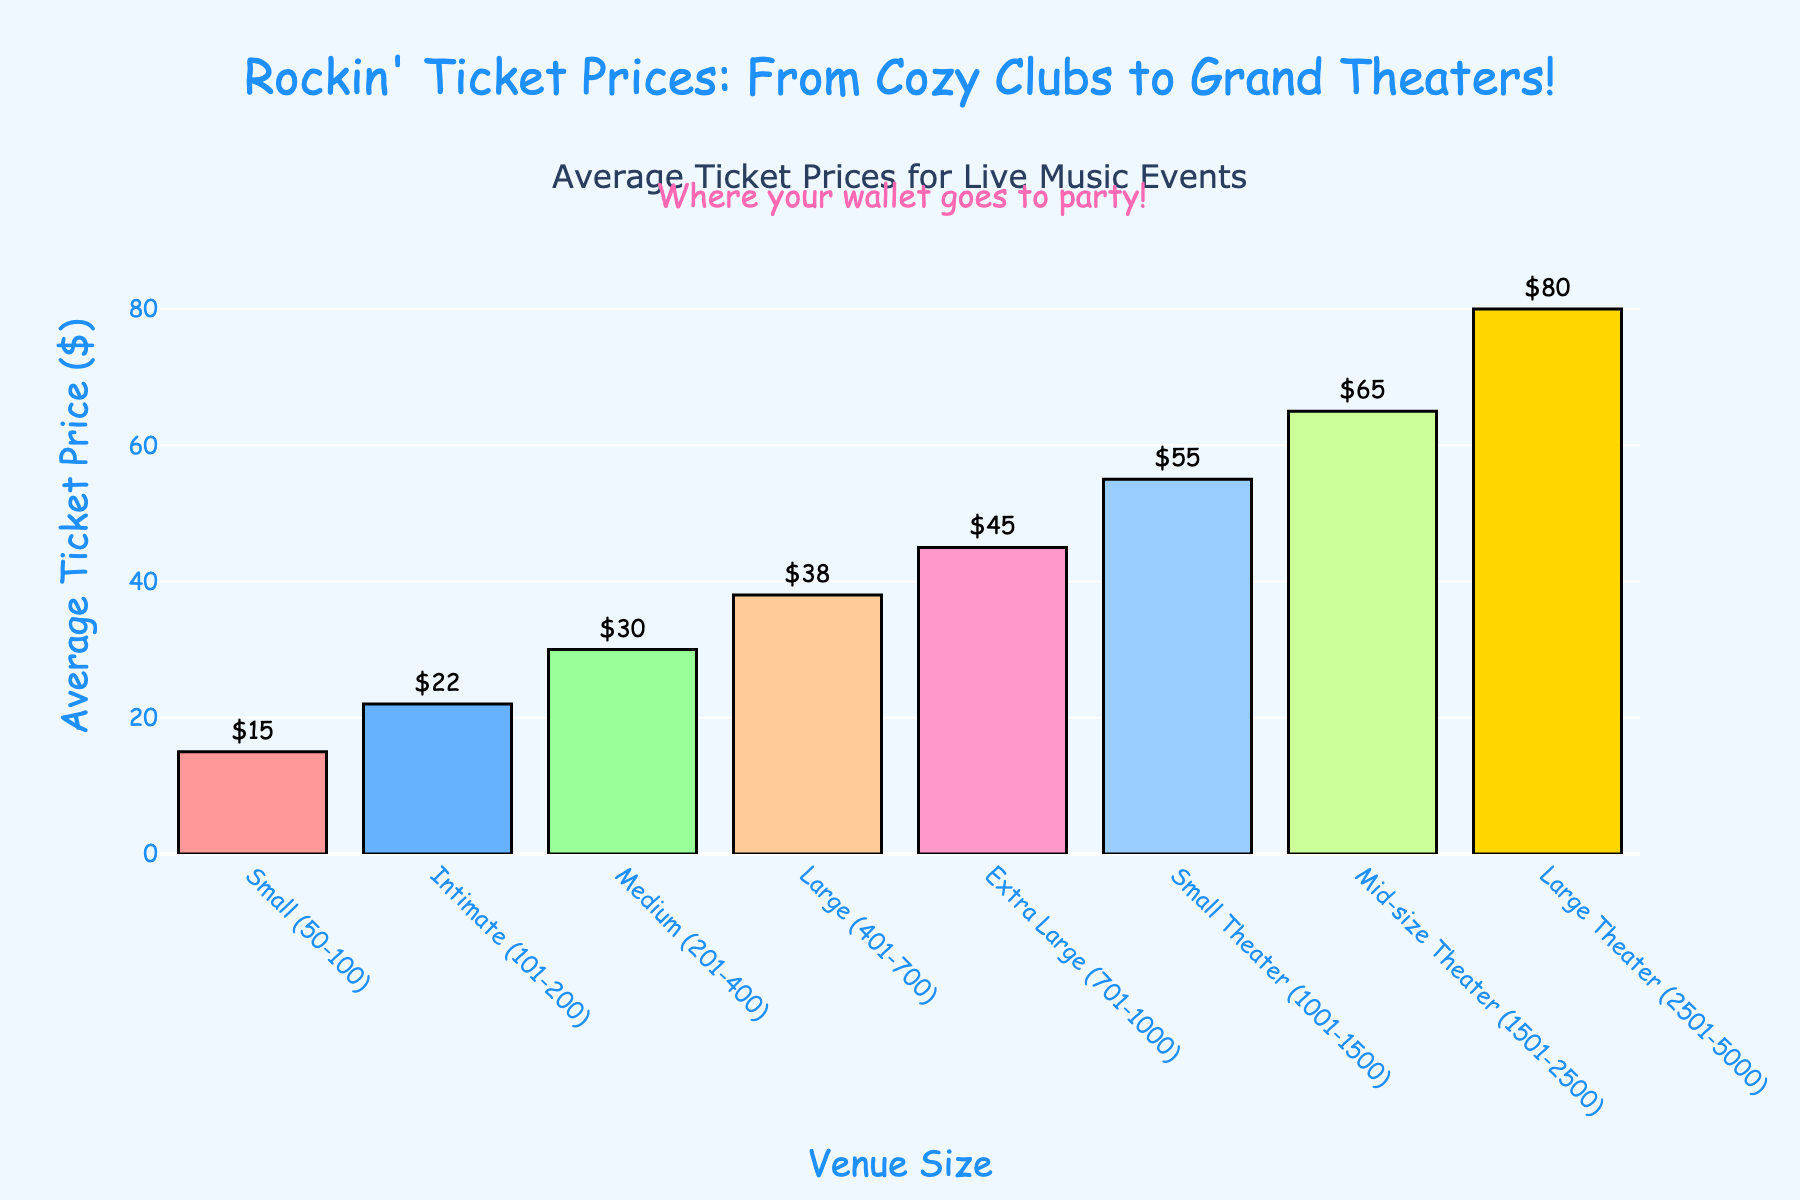what is the average ticket price for mid-size theaters (1501-2500 capacity)? The average ticket price is directly labeled on top of the bar representing mid-size theaters.
Answer: $65 Which club size has the highest average ticket price? The tallest bar in the chart represents the club size with the highest average ticket price, which corresponds to Large Theaters (2501-5000 capacity).
Answer: Large Theaters How much more expensive is a ticket at a Large Theater compared to a Medium-sized club? Identify the average ticket prices for Large Theaters ($80) and Medium clubs ($30), then subtract the price of Medium clubs from that of Large Theaters.
Answer: $50 What is the range of average ticket prices for club sizes ranging from Small (50–100 capacity) to Small Theater (1001–1500 capacity)? Identify the lowest and highest values within the specified range of club sizes: Small ($15) and Small Theater ($55), then subtract the lowest value from the highest value.
Answer: $40 Which club size has the second lowest average ticket price? Examine the heights of the bars and identify the second shortest bar. The second lowest average ticket price is for Intimate clubs (101-200 capacity).
Answer: Intimate (101-200) What is the total sum of average ticket prices for Small, Intimate, and Medium clubs? Add the values of the average ticket prices for Small ($15), Intimate ($22), and Medium clubs ($30).
Answer: $67 If you combined the average ticket prices for Large and Extra Large clubs, what would be the total? Add the average ticket prices for Large clubs ($38) and Extra Large clubs ($45).
Answer: $83 What is the average ticket price for club sizes over 1000 capacity? Identify and sum the average ticket prices for Small Theater ($55), Mid-size Theater ($65), and Large Theater ($80), then divide by 3. Calculation: (55 + 65 + 80) / 3.
Answer: $66.67 Which club sizes have tickets prices shown in green and yellow respectively? The color green represents Medium (201-400 capacity) with a ticket price of $30, and the color yellow represents Large Theater (2501-5000 capacity) with a ticket price of $80.
Answer: Medium ($30) and Large Theater ($80) 